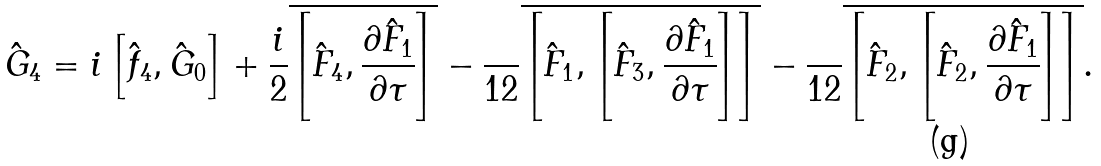Convert formula to latex. <formula><loc_0><loc_0><loc_500><loc_500>\hat { G } _ { 4 } = i \left [ \hat { f } _ { 4 } , \hat { G } _ { 0 } \right ] + \frac { i } { 2 } \overline { \left [ \hat { F } _ { 4 } , \frac { \partial \hat { F } _ { 1 } } { \partial \tau } \right ] } - \frac { } { 1 2 } \overline { \left [ \hat { F } _ { 1 } , \left [ \hat { F } _ { 3 } , \frac { \partial \hat { F } _ { 1 } } { \partial \tau } \right ] \right ] } - \frac { } { 1 2 } \overline { \left [ \hat { F } _ { 2 } , \left [ \hat { F } _ { 2 } , \frac { \partial \hat { F } _ { 1 } } { \partial \tau } \right ] \right ] } .</formula> 